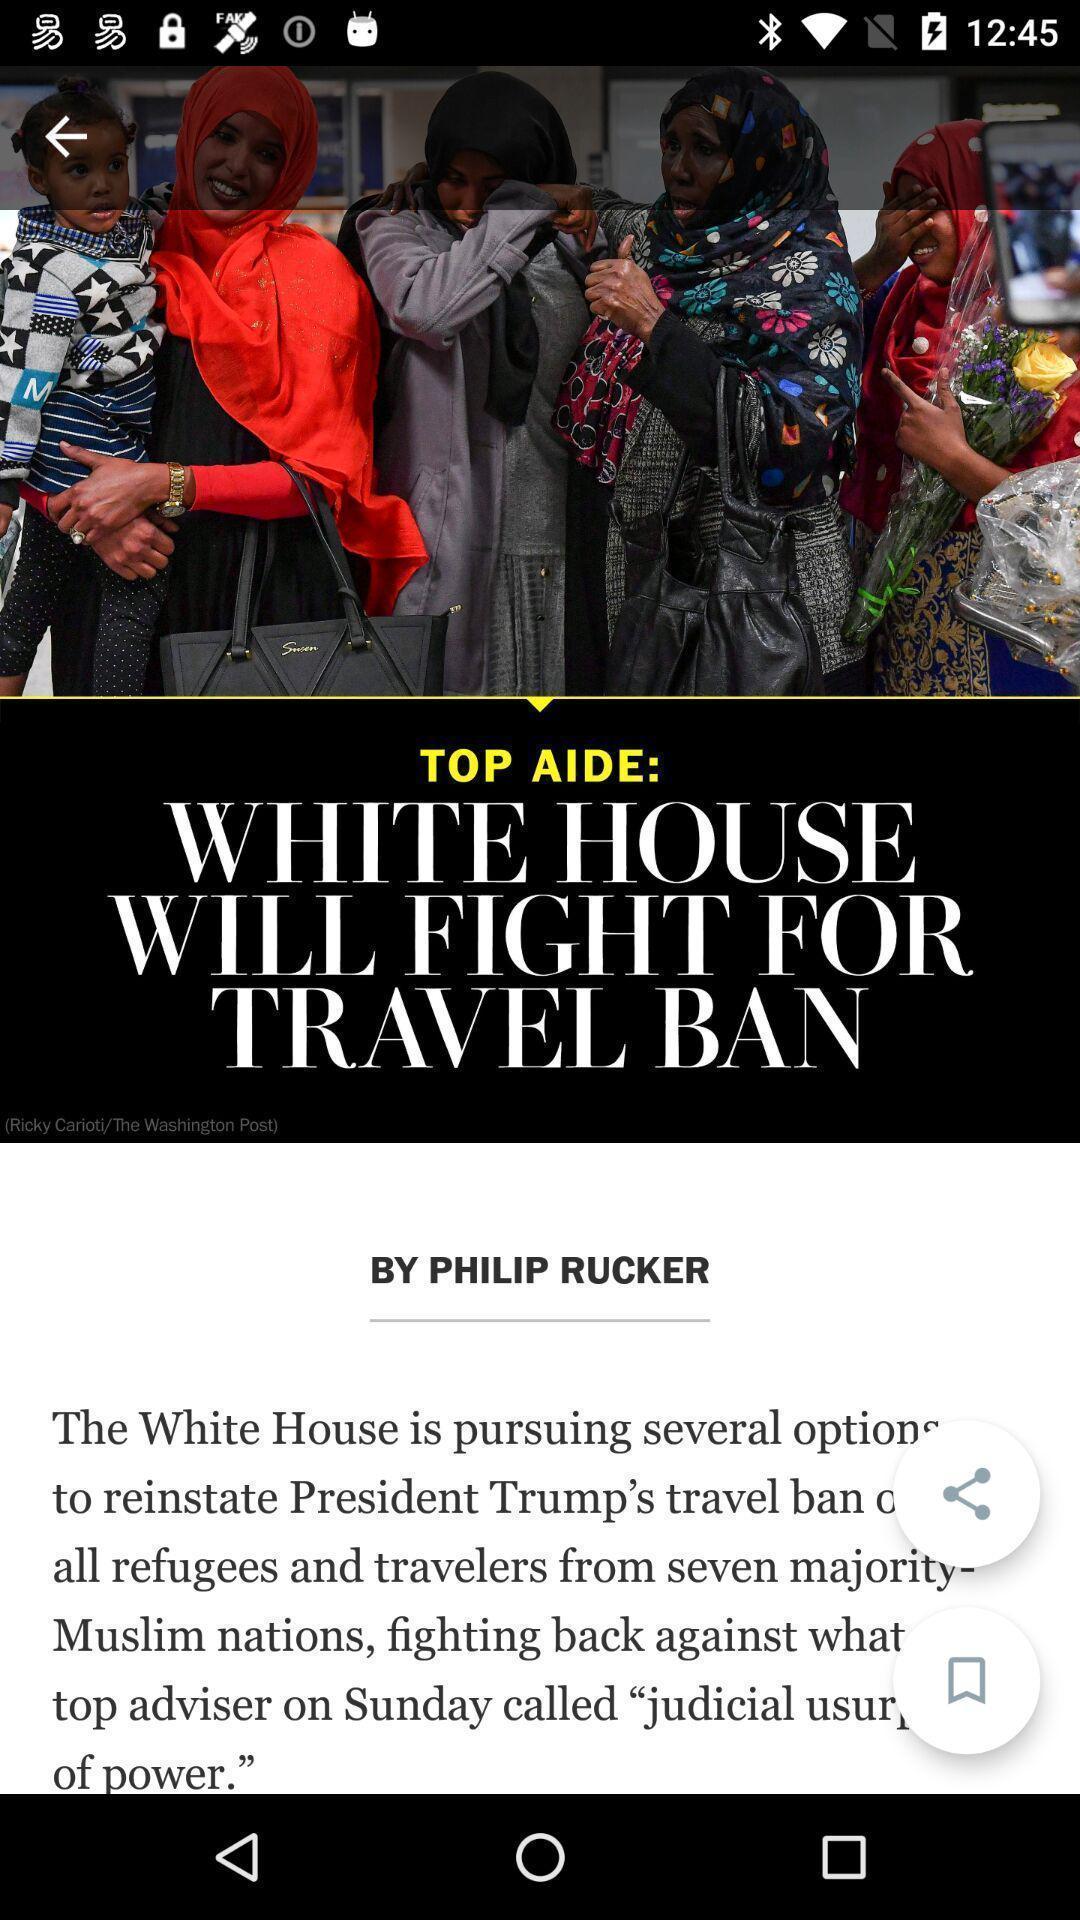Tell me what you see in this picture. Screen displaying top news on an app. 